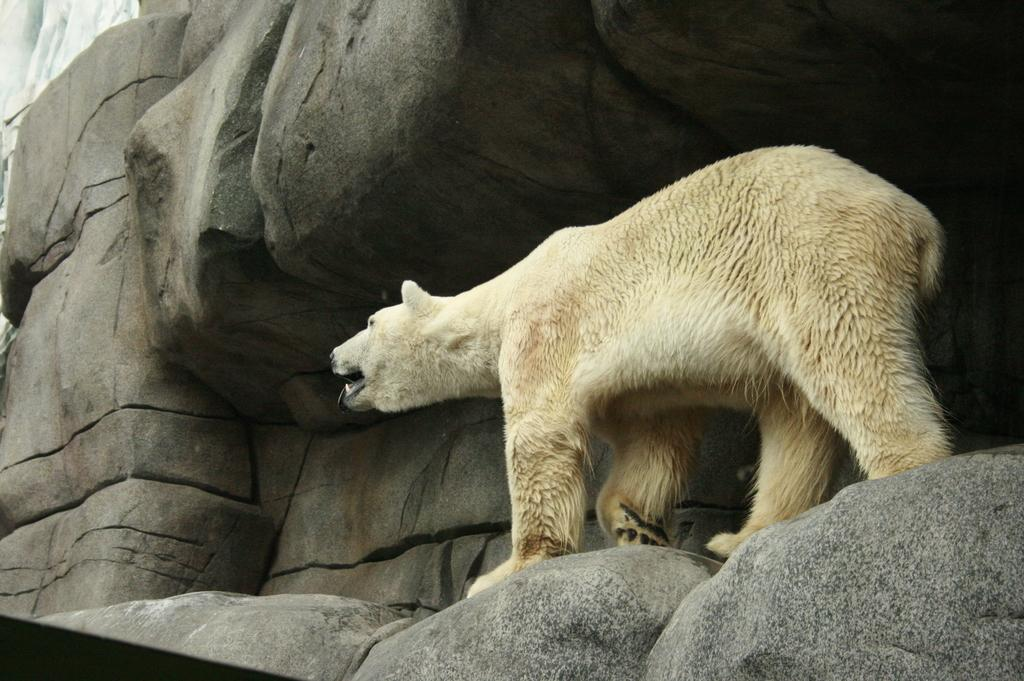What type of animal is in the image? There is a Thai cat in the image. Where is the cat located in the image? The cat is walking on a mountain. How many apples can be seen in the image? There are no apples present in the image. What type of ground is the cat walking on in the image? The ground is not specified in the image, but it is likely a mountainous terrain. 